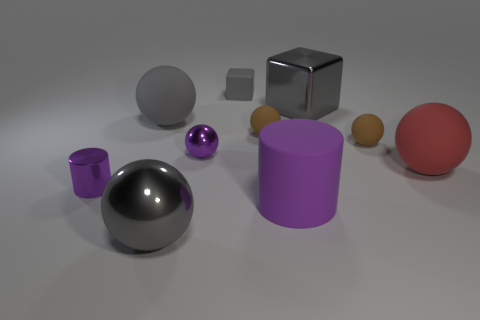Subtract all gray spheres. How many spheres are left? 4 Subtract 1 spheres. How many spheres are left? 5 Subtract all gray metal spheres. How many spheres are left? 5 Subtract all gray spheres. Subtract all red blocks. How many spheres are left? 4 Subtract all cylinders. How many objects are left? 8 Add 4 small purple things. How many small purple things are left? 6 Add 4 big gray things. How many big gray things exist? 7 Subtract 0 cyan spheres. How many objects are left? 10 Subtract all purple cubes. Subtract all red spheres. How many objects are left? 9 